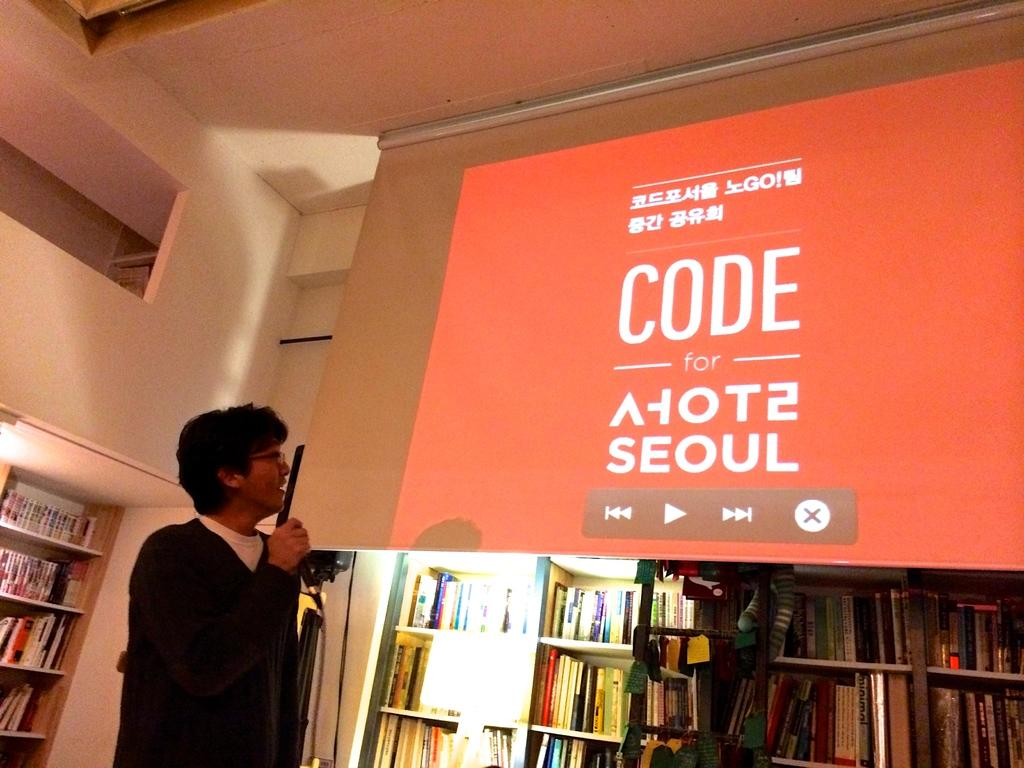<image>
Render a clear and concise summary of the photo. A bookstore with  a red sign advertising a code with a play button on it. 